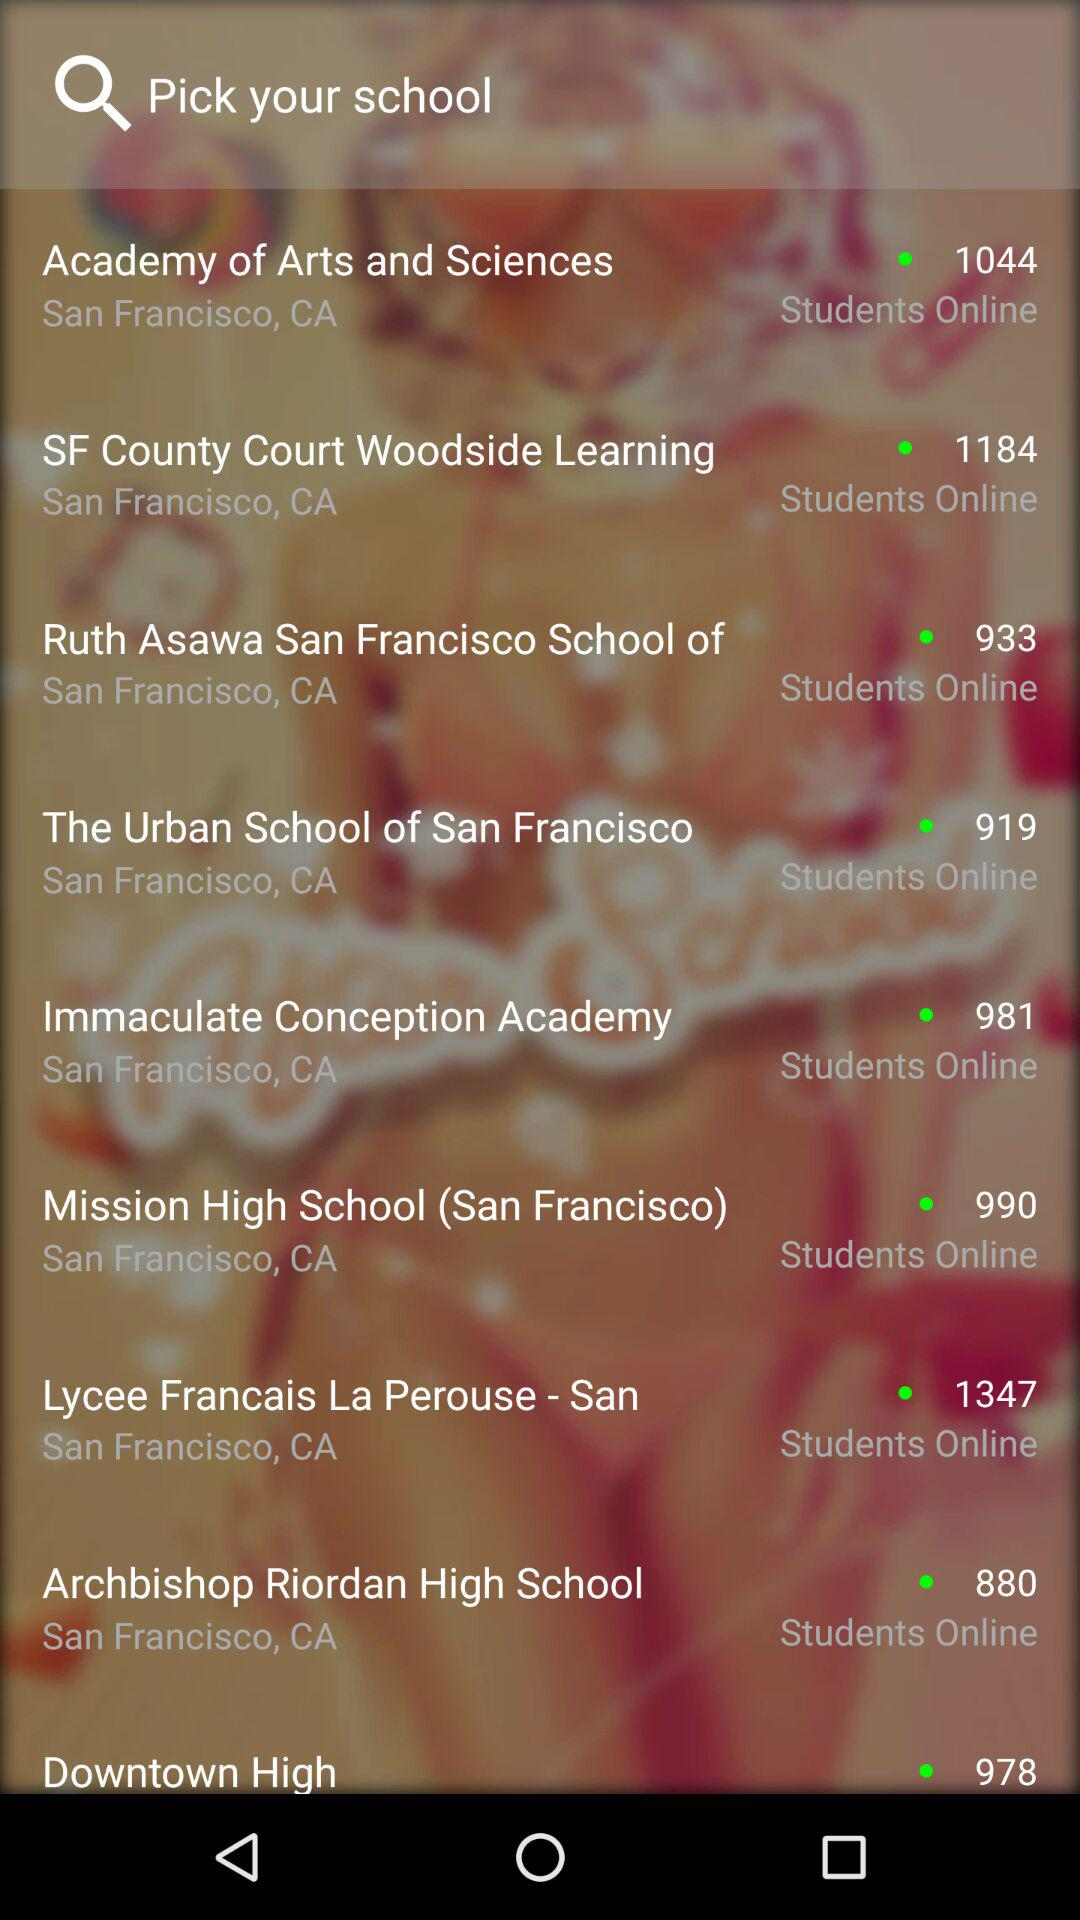How many students of the "Academy of Arts and Sciences" are online? The number of students who are online is 1044. 